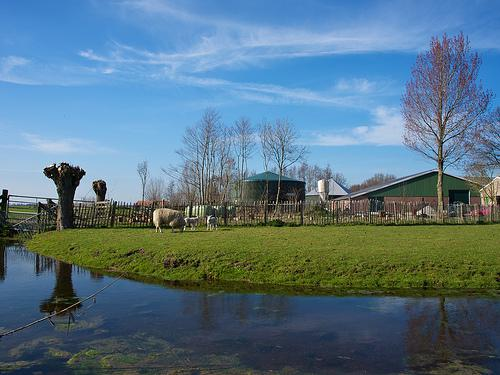Question: where is the lamb?
Choices:
A. On the log.
B. On the ground.
C. On the hay.
D. On the grass.
Answer with the letter. Answer: D Question: what is green?
Choices:
A. The grass.
B. The field.
C. The tree.
D. The lawn.
Answer with the letter. Answer: A Question: when is it?
Choices:
A. Morning time.
B. Breakfast time.
C. Nighttime.
D. Day time.
Answer with the letter. Answer: D 